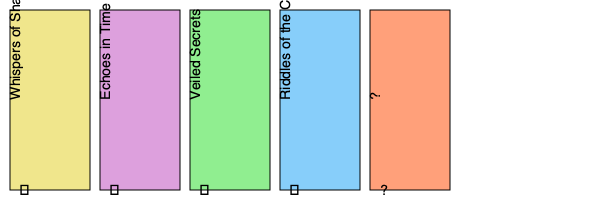Based on the pattern of book titles and symbols, what should replace the question marks on the final book spine and beneath it? To solve this enigmatic sequence, we need to analyze both the book titles and the symbols beneath them:

1. Book titles:
   - "Whispers of Shadows"
   - "Echoes in Time"
   - "Veiled Secrets"
   - "Riddles of the Cosmos"
   
   The pattern seems to be related to mysterious and cryptic concepts, each becoming more expansive in scope. The progression goes from shadows to time, then to secrets, and finally to the cosmos.

2. Symbols:
   - ♠ (Spades)
   - ♣ (Clubs)
   - ♥ (Hearts)
   - ♦ (Diamonds)
   
   These are the four suits in a standard deck of playing cards, presented in a specific order.

3. Pattern analysis:
   - The book titles progress from personal ("Whispers") to universal ("Cosmos").
   - The symbols follow the order of card suits.

4. Deducing the final elements:
   - For the book title: Following the pattern of expanding scope, the next logical step after "Cosmos" would be something even more all-encompassing. "Enigmas of Existence" fits this pattern.
   - For the symbol: After completing the four suits, the logical next step would be to return to the first suit, which is Spades (♠).

Therefore, the final book spine should read "Enigmas of Existence" with the symbol ♠ beneath it.
Answer: Enigmas of Existence, ♠ 